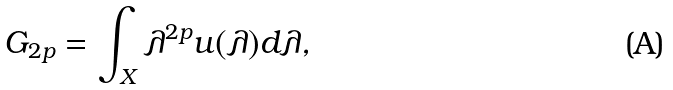Convert formula to latex. <formula><loc_0><loc_0><loc_500><loc_500>G _ { 2 p } = \int _ { X } \lambda ^ { 2 p } u ( \lambda ) d \lambda ,</formula> 